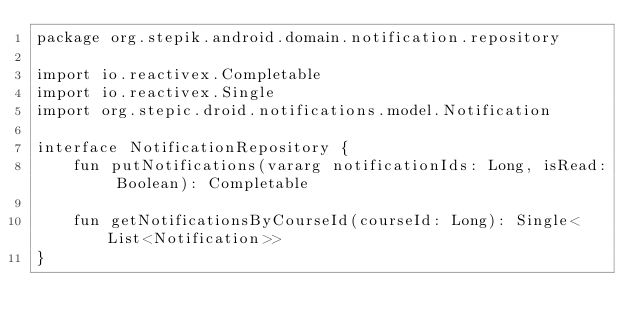Convert code to text. <code><loc_0><loc_0><loc_500><loc_500><_Kotlin_>package org.stepik.android.domain.notification.repository

import io.reactivex.Completable
import io.reactivex.Single
import org.stepic.droid.notifications.model.Notification

interface NotificationRepository {
    fun putNotifications(vararg notificationIds: Long, isRead: Boolean): Completable

    fun getNotificationsByCourseId(courseId: Long): Single<List<Notification>>
}</code> 